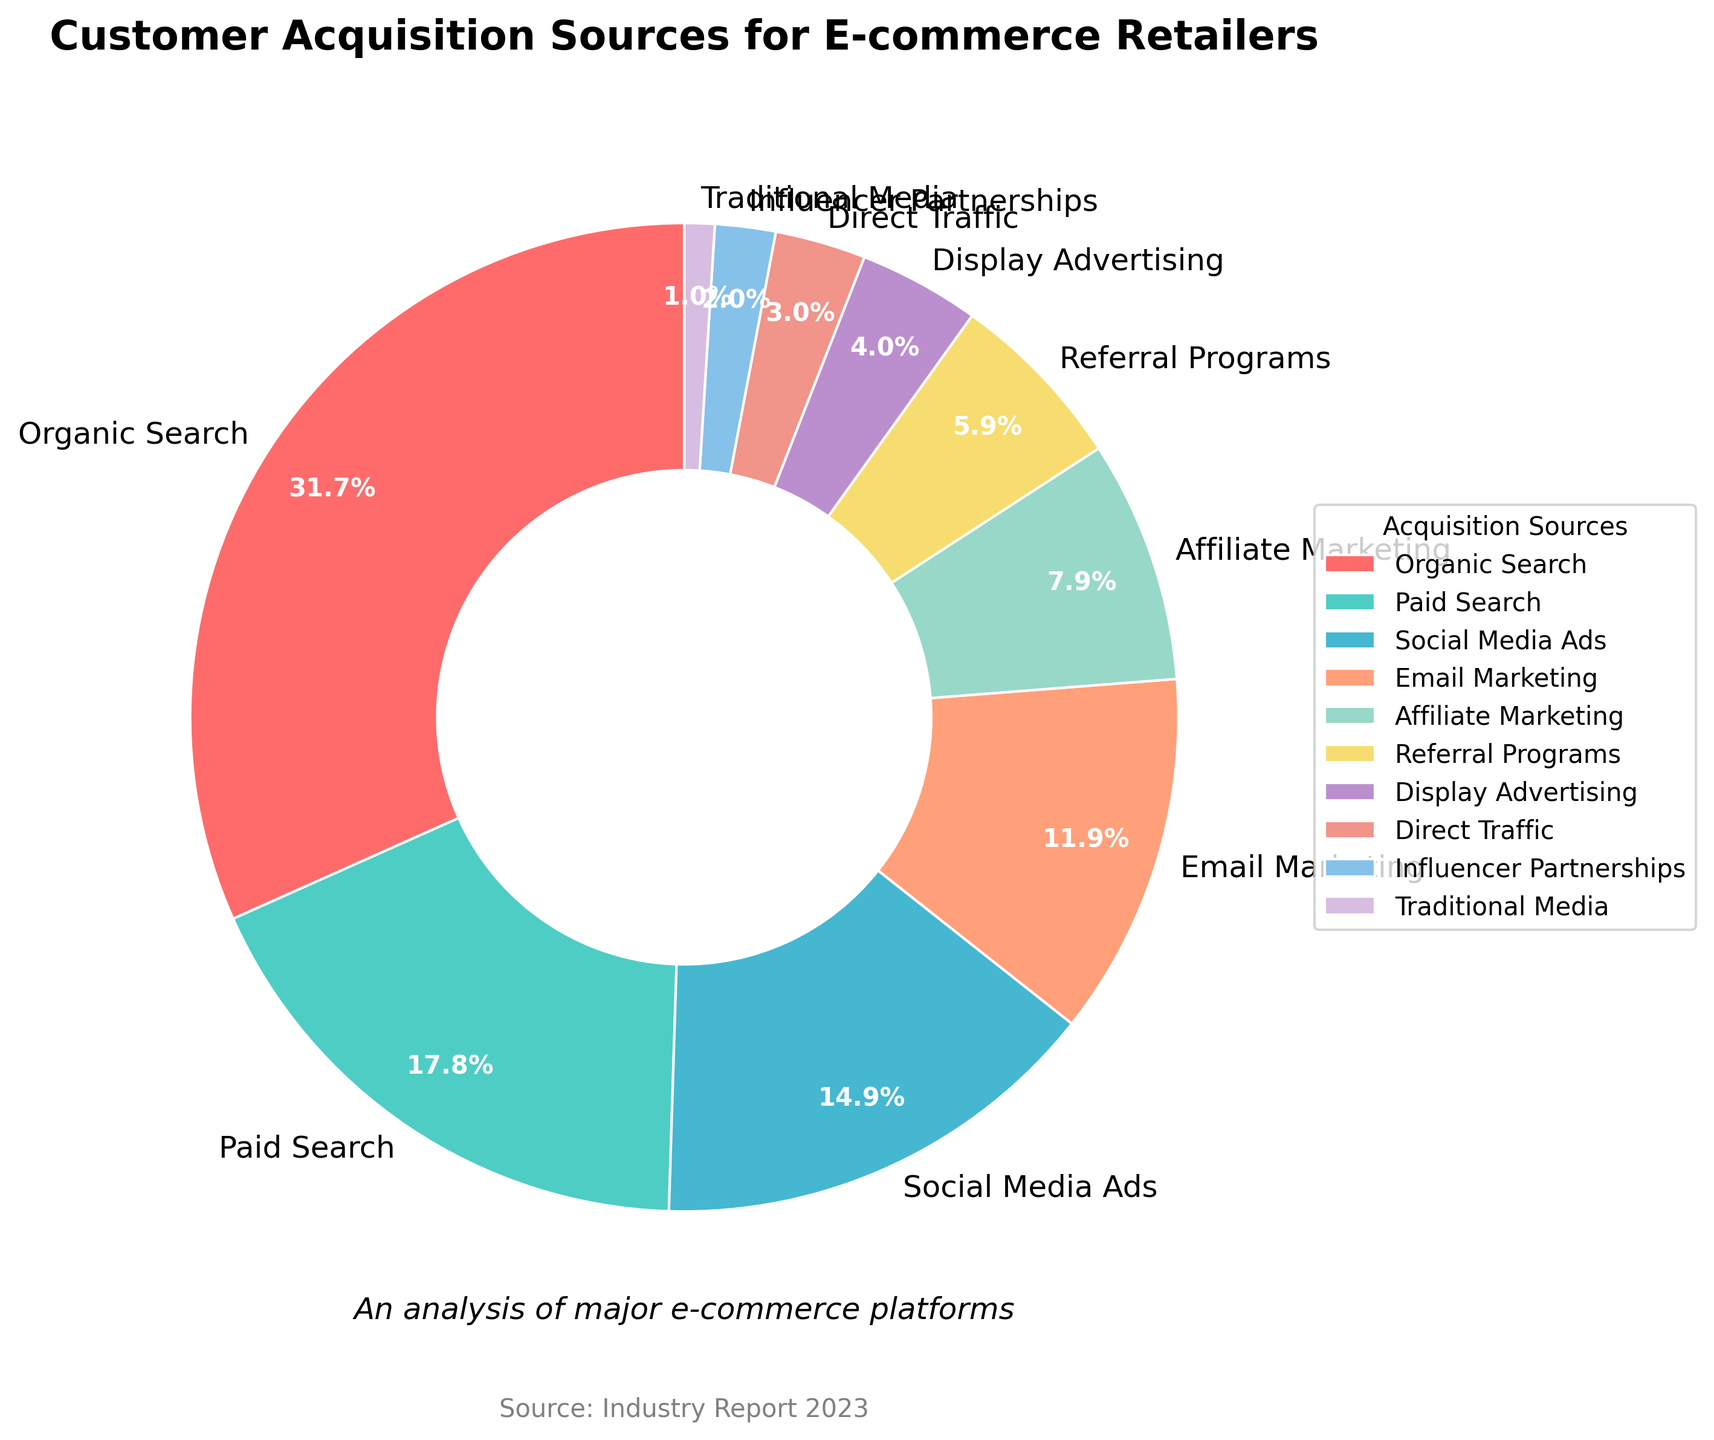What's the largest source of customer acquisition? The largest segment in the pie chart corresponds to the source with the highest percentage. According to the data, Organic Search makes up 32% of the total, which is the largest share.
Answer: Organic Search Which source has the smallest percentage of customer acquisition? The smallest segment in the pie chart is directly observable as the smallest wedge. According to the data, Traditional Media makes up only 1% of the total.
Answer: Traditional Media How much higher is Organic Search compared to Paid Search? Organic Search is 32%, and Paid Search is 18%. The difference can be calculated by subtracting the smaller percentage from the larger one: 32% - 18% = 14%.
Answer: 14% What is the combined percentage of Social Media Ads and Email Marketing? Sum the percentages of the two sources: Social Media Ads (15%) + Email Marketing (12%) = 27%.
Answer: 27% Which sources together make up exactly half of the total customer acquisition? To find sources that together make up 50%, we need to sum combinations of percentages and check if they equal 50%. Organic Search (32%) combined with Social Media Ads (15%) is the closest at 47%. Organic Search (32%) combined with Paid Search (18%) is slightly over at 50%. Therefore, Organic Search and Paid Search combine to make 50%.
Answer: Organic Search and Paid Search Which is greater: the combined percentage of Display Advertising and Influencer Partnerships, or Affiliate Marketing? Display Advertising and Influencer Partnerships add up to: 4% + 2% = 6%. Affiliate Marketing alone is 8%. Since 6% is less than 8%, Affiliate Marketing is greater.
Answer: Affiliate Marketing Identify the source represented by the green color in the pie chart. According to the provided color order, the second color (#4ECDC4) is green and it corresponds to Paid Search.
Answer: Paid Search How much less is Referral Programs compared to Social Media Ads? Referral Programs is 6%, and Social Media Ads is 15%. The difference can be found by subtracting Referral Programs' percentage from Social Media Ads' percentage: 15% - 6% = 9%.
Answer: 9% What is the total percentage of all sources excluding Organic Search and Paid Search? First, sum the percentages of Organic Search and Paid Search: 32% + 18% = 50%. Subtract this from 100% (the total): 100% - 50% = 50%.
Answer: 50% Which has a higher percentage: Direct Traffic or Influencer Partnerships, and by how much? Direct Traffic is 3% and Influencer Partnerships is 2%. The difference is calculated: 3% - 2% = 1%. Direct Traffic has a higher percentage by 1%.
Answer: Direct Traffic by 1% 